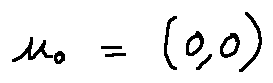<formula> <loc_0><loc_0><loc_500><loc_500>u _ { 0 } = ( 0 , 0 )</formula> 